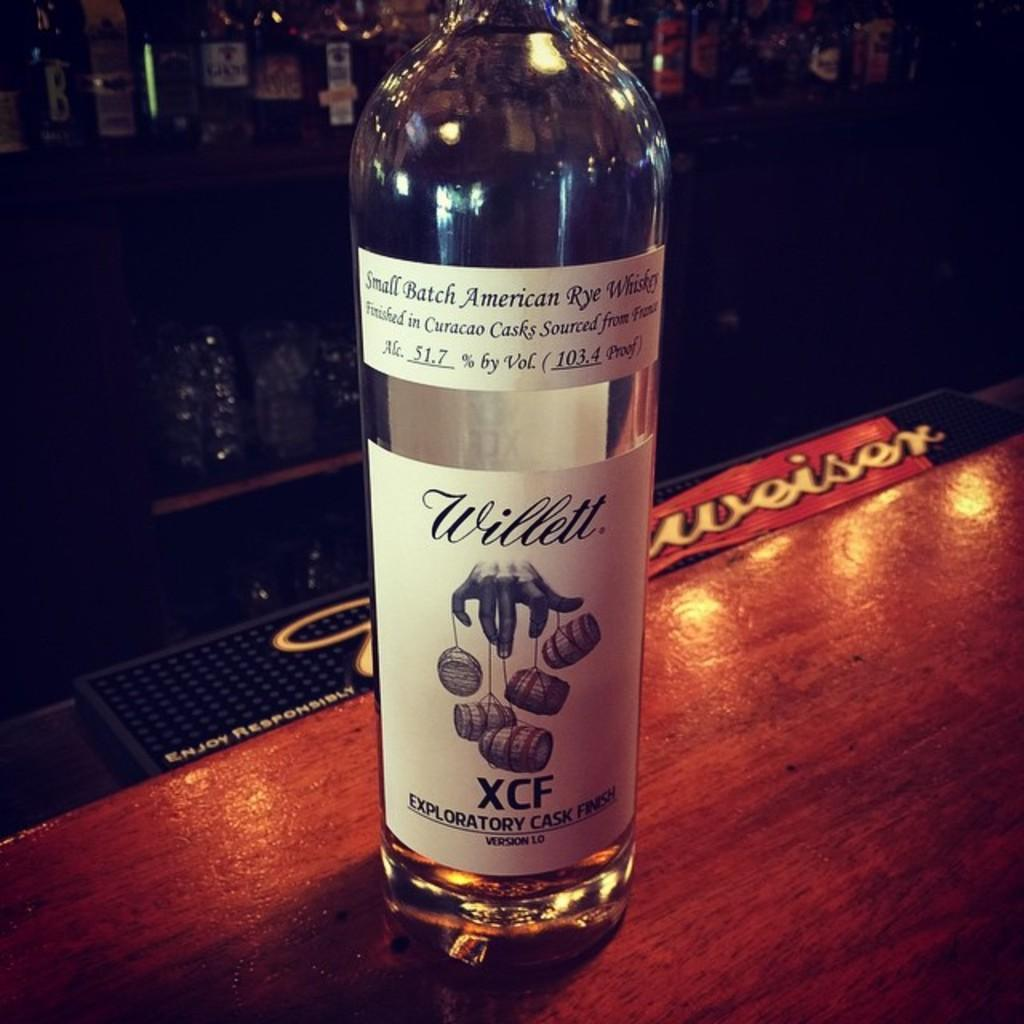What object can be seen in the image? There is a bottle in the image. Where is the bottle located? The bottle is on top of a table. What type of throne is depicted in the image? There is no throne present in the image; it only features a bottle on a table. What color is the collar on the bottle in the image? There is no collar present on the bottle in the image. 